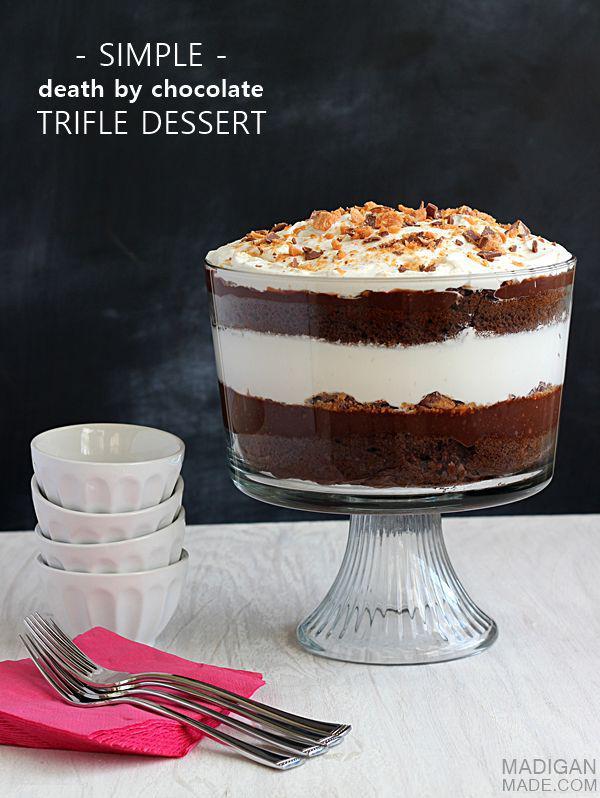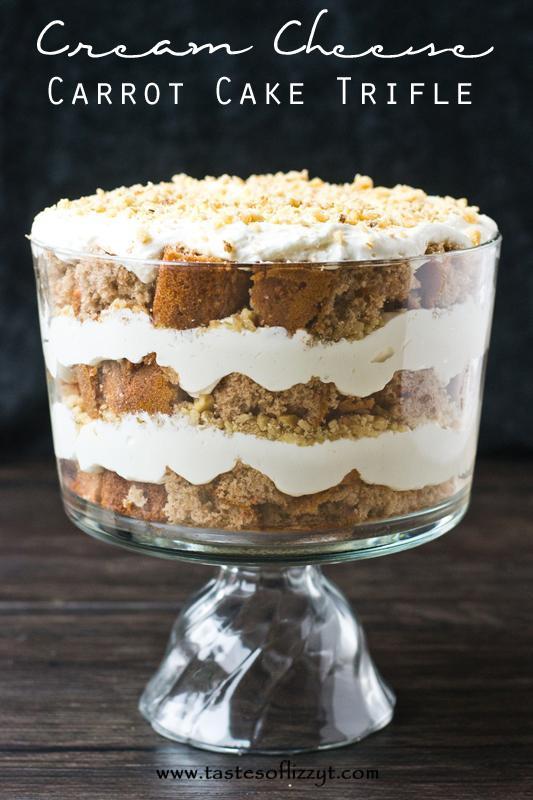The first image is the image on the left, the second image is the image on the right. For the images shown, is this caption "One image shows three servings of layered dessert that are not displayed in one horizontal row." true? Answer yes or no. No. The first image is the image on the left, the second image is the image on the right. Given the left and right images, does the statement "Two large trifle desserts are made in clear bowls with alernating cake and creamy layers, ending with a garnished creamy top." hold true? Answer yes or no. Yes. 